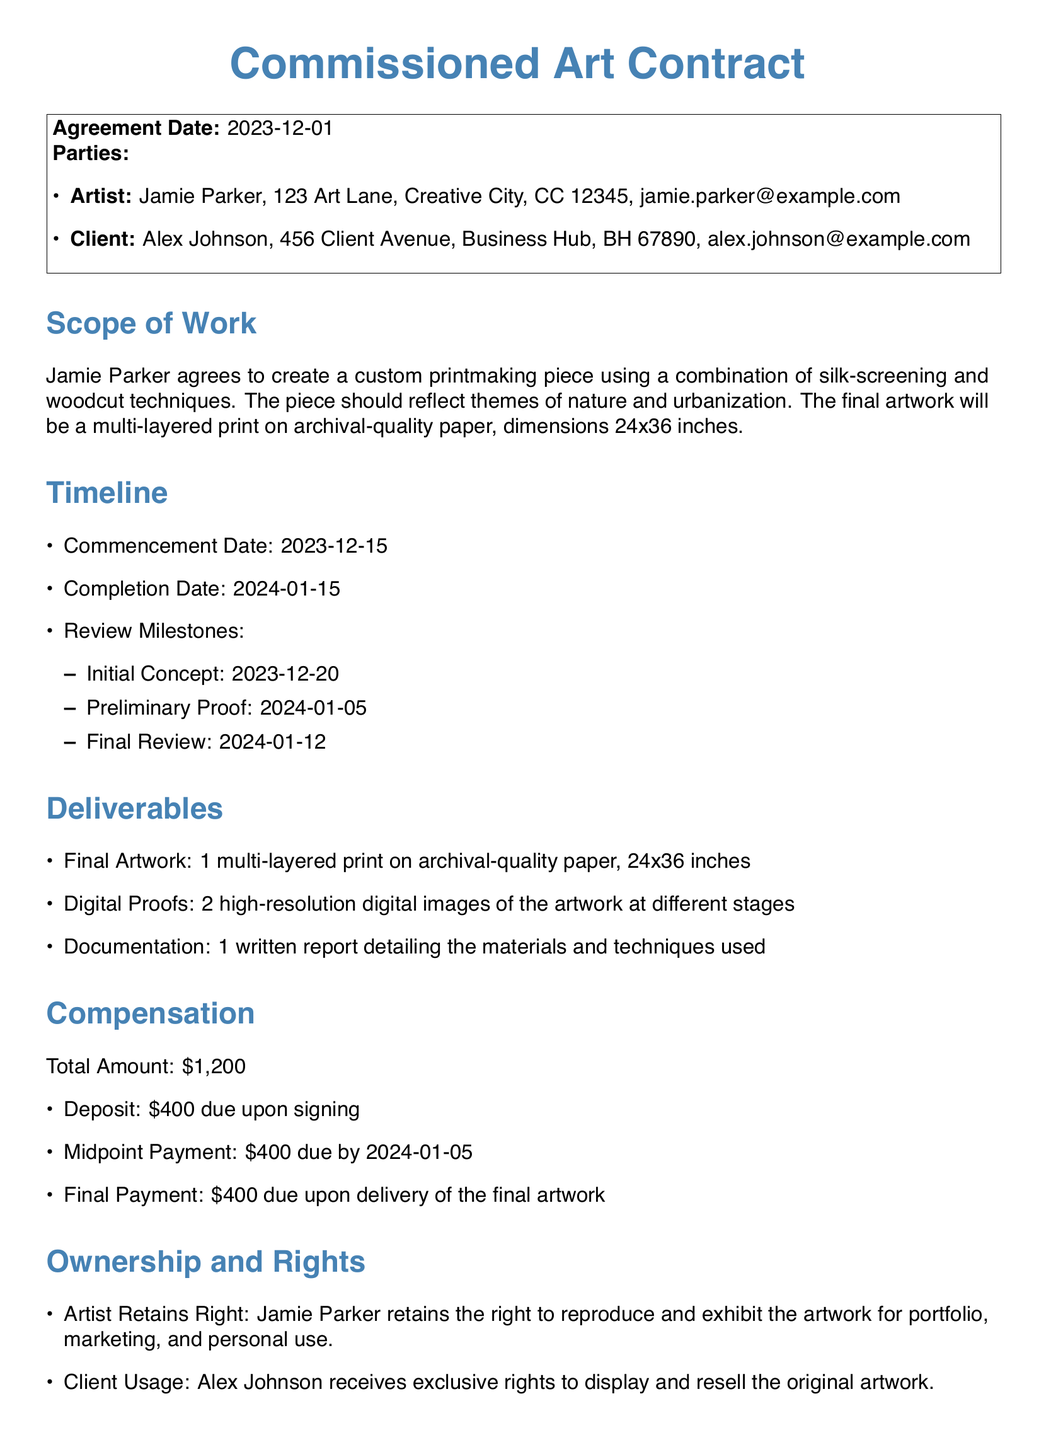What is the agreement date? The agreement date is mentioned at the beginning of the document and is a specific date related to the contract.
Answer: 2023-12-01 Who is the artist? The artist's name is listed in the "Parties" section of the document as the creator of the commissioned artwork.
Answer: Jamie Parker What is the completion date? The completion date is specified in the "Timeline" section and indicates when the project should be finished.
Answer: 2024-01-15 What dimensions should the final print have? The dimensions of the final artwork are given in the "Scope of Work", which provides details about the size.
Answer: 24x36 inches What is the total compensation amount? The total compensation amount is outlined clearly in the "Compensation" section, summarizing the financial agreement between the parties.
Answer: $1,200 What is the cancellation fee? The cancellation fee is stated under the "Cancellation and Modifications" section and outlines financial consequences if the client cancels.
Answer: $200 What rights does the artist retain? The rights retained by the artist regarding their work are specified in the "Ownership and Rights" section of the document.
Answer: Right to reproduce and exhibit When is the initial concept review milestone? The document specifies review milestones and dates, indicating when different stages of the artwork are due for review.
Answer: 2023-12-20 What is the deposit amount due upon signing? The deposit amount is clearly listed in the "Compensation" section as a requirement when the contract is signed.
Answer: $400 